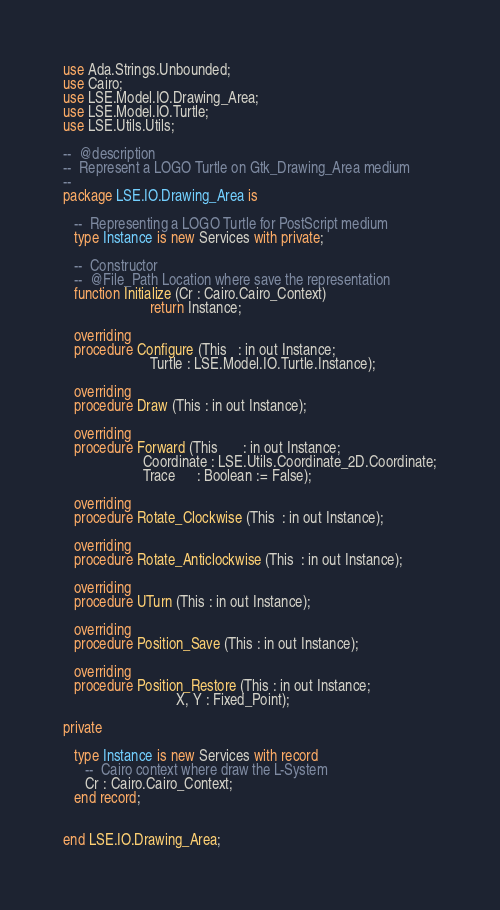Convert code to text. <code><loc_0><loc_0><loc_500><loc_500><_Ada_>
use Ada.Strings.Unbounded;
use Cairo;
use LSE.Model.IO.Drawing_Area;
use LSE.Model.IO.Turtle;
use LSE.Utils.Utils;

--  @description
--  Represent a LOGO Turtle on Gtk_Drawing_Area medium
--
package LSE.IO.Drawing_Area is

   --  Representing a LOGO Turtle for PostScript medium
   type Instance is new Services with private;

   --  Constructor
   --  @File_Path Location where save the representation
   function Initialize (Cr : Cairo.Cairo_Context)
                        return Instance;

   overriding
   procedure Configure (This   : in out Instance;
                        Turtle : LSE.Model.IO.Turtle.Instance);

   overriding
   procedure Draw (This : in out Instance);

   overriding
   procedure Forward (This       : in out Instance;
                      Coordinate : LSE.Utils.Coordinate_2D.Coordinate;
                      Trace      : Boolean := False);

   overriding
   procedure Rotate_Clockwise (This  : in out Instance);

   overriding
   procedure Rotate_Anticlockwise (This  : in out Instance);

   overriding
   procedure UTurn (This : in out Instance);

   overriding
   procedure Position_Save (This : in out Instance);

   overriding
   procedure Position_Restore (This : in out Instance;
                               X, Y : Fixed_Point);

private

   type Instance is new Services with record
      --  Cairo context where draw the L-System
      Cr : Cairo.Cairo_Context;
   end record;


end LSE.IO.Drawing_Area;
</code> 